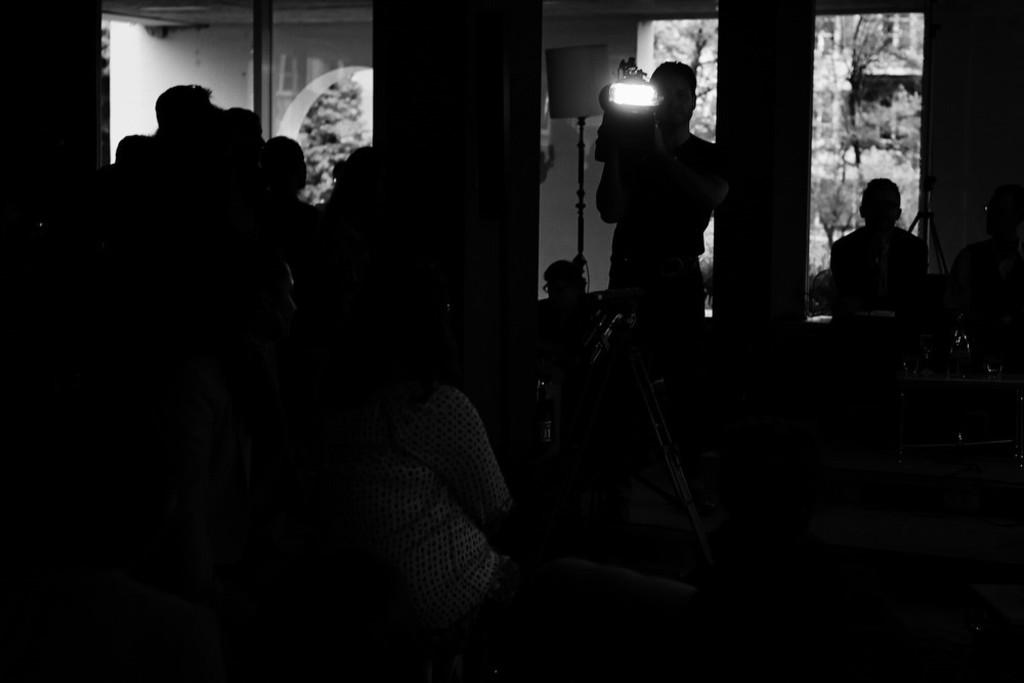How would you describe the overall lighting in the image? The image is dark. What objects can be seen in the image that are used for support or display? There are stands in the image. Are there any people present in the image? Yes, there are people in the image. Can you describe a specific object that combines a light source and a stand? There is a lamp with a stand in the image. What is the man in the image doing with a light? A man is holding a light in the image. What type of minister is present in the image? There is no minister present in the image. What is the current being used for in the image? There is no mention of a current or any electrical device in the image. 